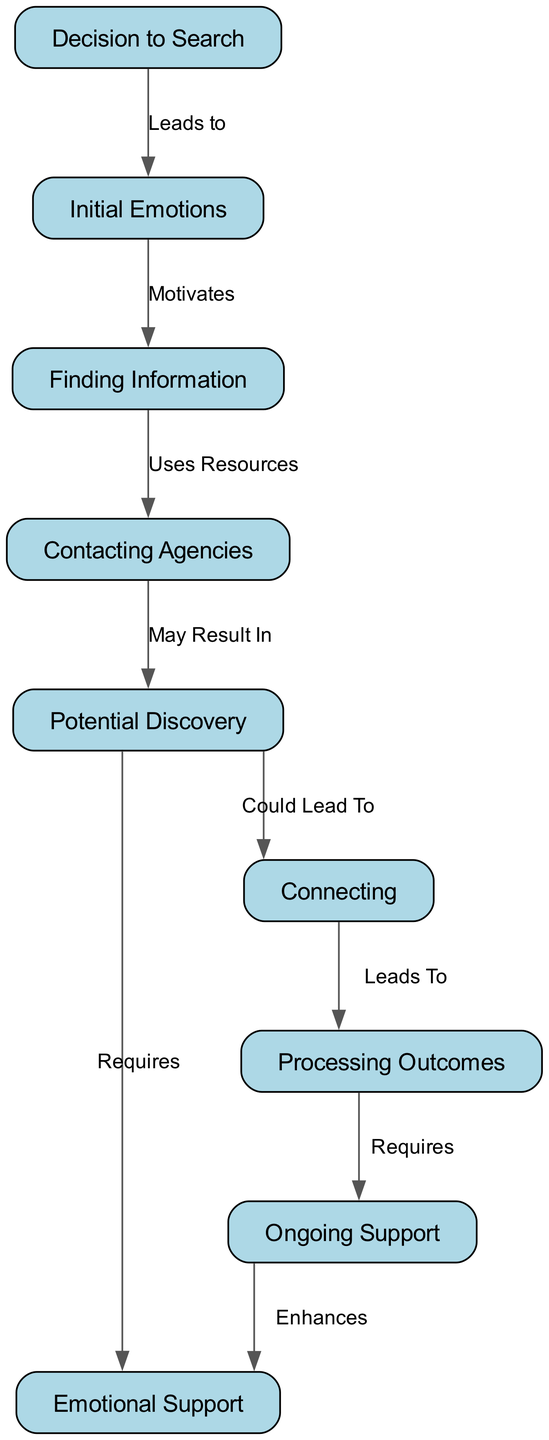What is the first step in the search process? The first step is indicated by the starting node in the diagram, which is labeled "Decision to Search."
Answer: Decision to Search How many nodes are in the diagram? By counting all the labeled steps, there are a total of 9 nodes as depicted in the diagram.
Answer: 9 What leads to initial emotions? The diagram shows that the "Decision to Search" leads to "Initial Emotions."
Answer: Decision to Search What is required after potential discovery? After "Potential Discovery," the diagram indicates that "Emotional Support" is required.
Answer: Emotional Support What is the relationship between connecting and processing outcomes? The diagram states that "Connecting" leads to "Processing Outcomes."
Answer: Leads To What motivates the search for finding information? The diagram specifies that "Initial Emotions" motivate the search for "Finding Information."
Answer: Motivates What enhances ongoing support? According to the diagram, "Ongoing Support" is enhanced by "Emotional Support."
Answer: Enhances How many edges are in the diagram? By analyzing the connections between the nodes, there are a total of 8 edges depicted in the diagram.
Answer: 8 What step follows contacting agencies? The diagram indicates that "Contacting Agencies" is followed by "Potential Discovery."
Answer: Potential Discovery 